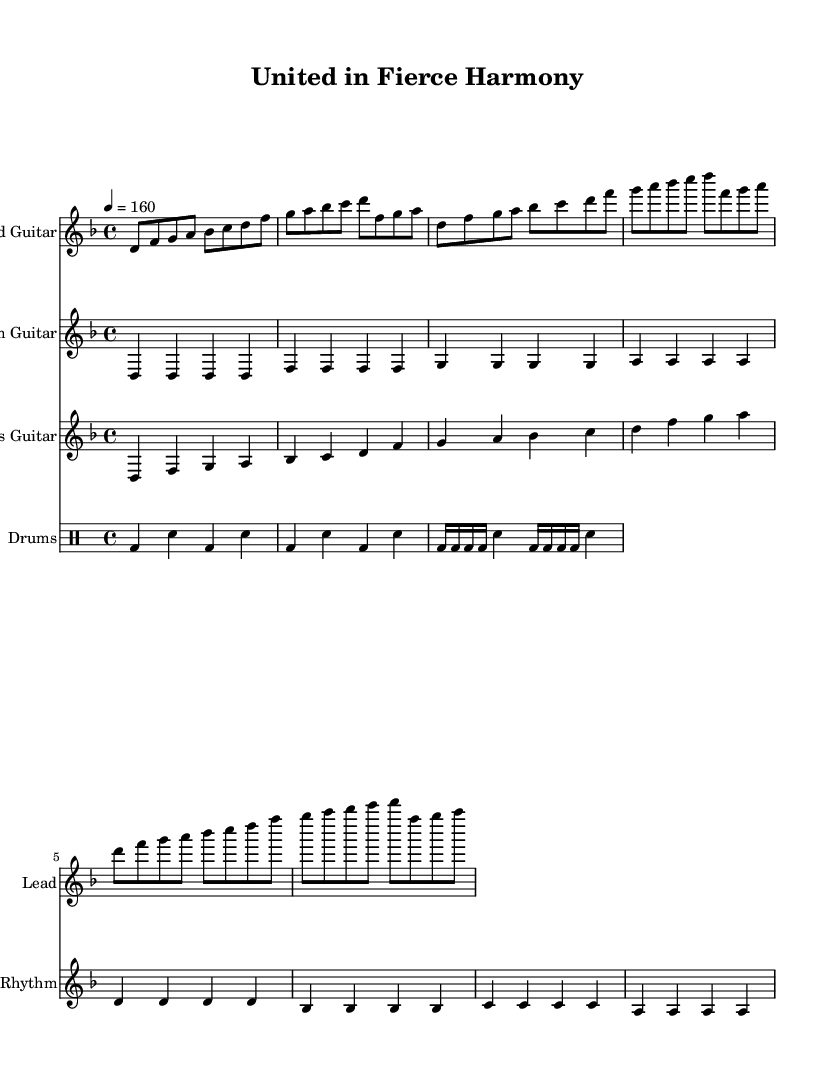What is the key signature of this music? The key signature of the music is D minor, which is indicated by the presence of one flat in the key signature (B flat).
Answer: D minor What is the time signature of this piece? The time signature is found at the beginning of the score, which indicates that there are four beats in each measure, represented as 4/4.
Answer: 4/4 What is the tempo marking of this composition? The tempo marking is indicated at the beginning, showing that the piece should be played at a speed of 160 beats per minute.
Answer: 160 How many measures are there in the verse section for the lead guitar? The verse section for the lead guitar consists of two lines of music, with each line containing four measures, totaling eight measures.
Answer: 8 Which instrument plays the most complex rhythmic pattern? The rhythm guitar section features long, sustained notes, while the drums include a more complex pattern with snare and bass drum interplay, making the drums the most rhythmic in complexity.
Answer: Drums How many beats are in each measure of the drum part during the chorus? The drum part for the chorus is notated with 16th notes followed by a quarter note, indicating a total of four beats per measure, adhering to the 4/4 time signature.
Answer: 4 How does the lyrical theme connect to the overall style of the music? The lyrics, inspired by teamwork and camaraderie, align with the melodic death metal genre which often emphasizes unity and strength through heavy instrumentation and powerful melodies.
Answer: Teamwork and camaraderie 